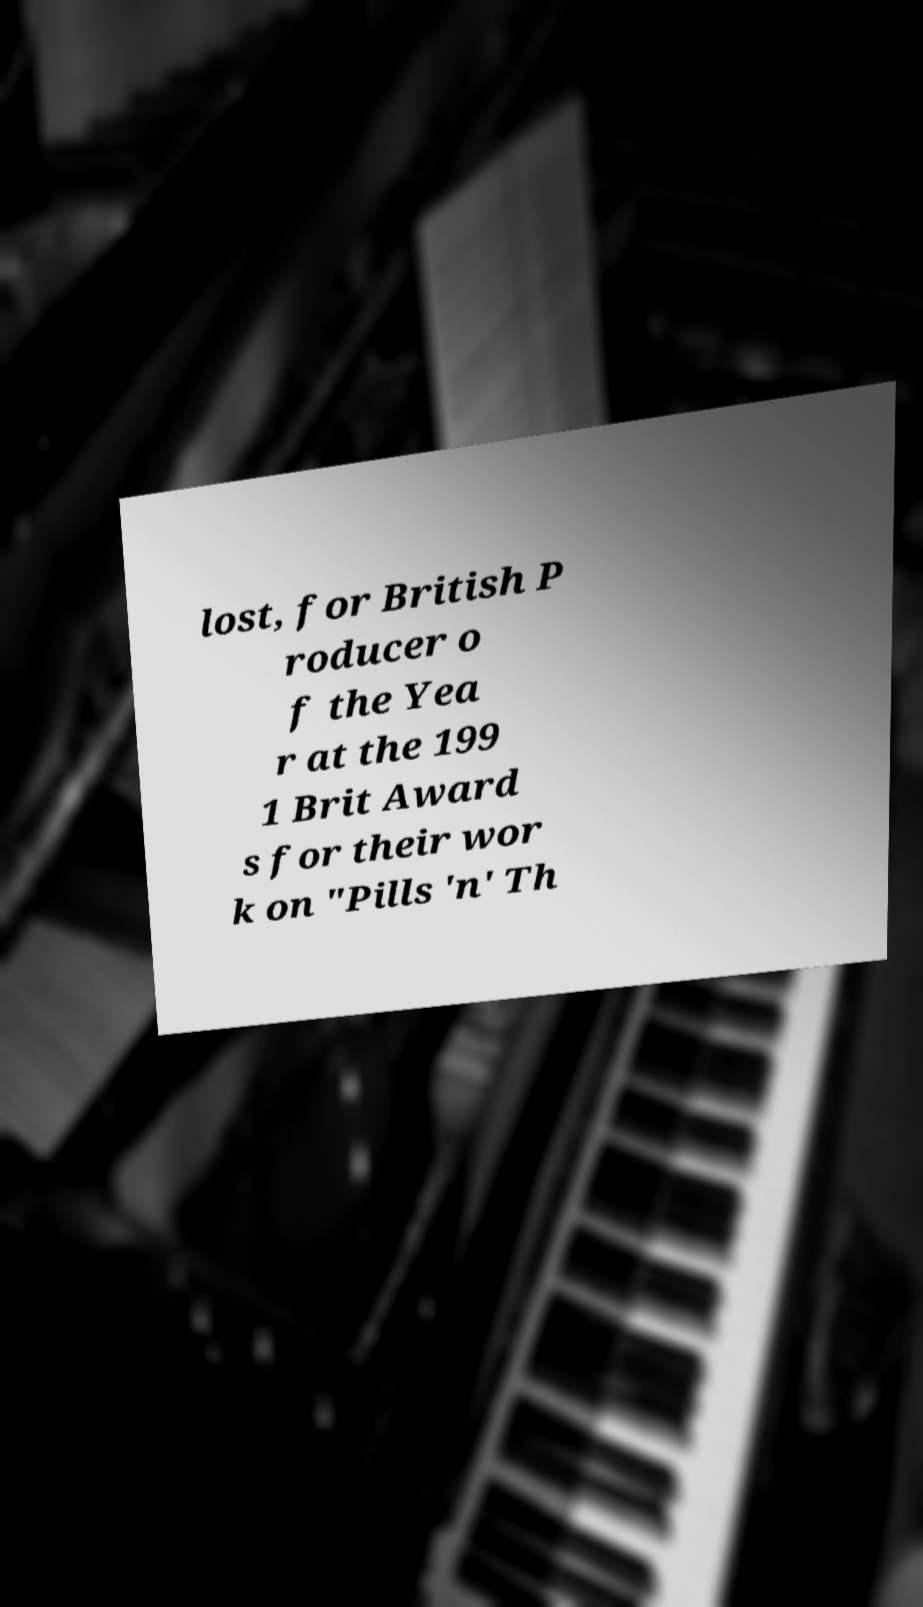Can you accurately transcribe the text from the provided image for me? lost, for British P roducer o f the Yea r at the 199 1 Brit Award s for their wor k on "Pills 'n' Th 